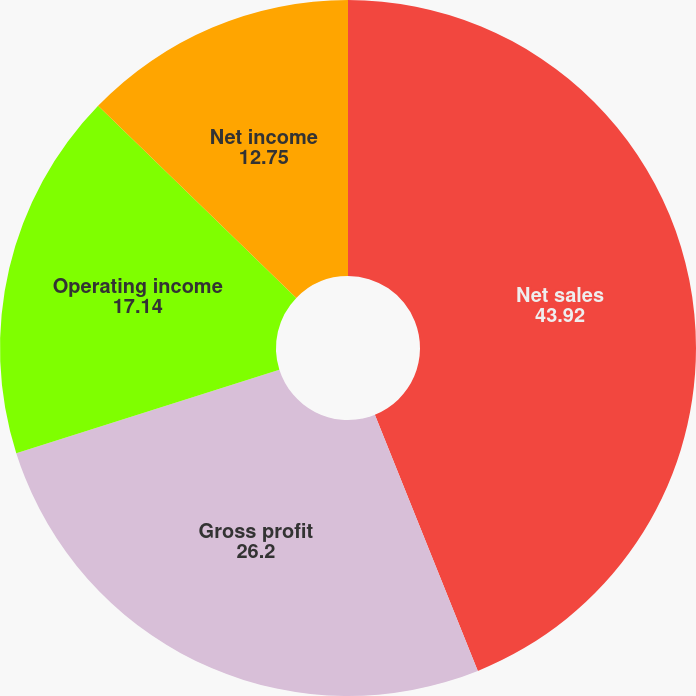<chart> <loc_0><loc_0><loc_500><loc_500><pie_chart><fcel>Net sales<fcel>Gross profit<fcel>Operating income<fcel>Net income<fcel>Diluted net income per common<nl><fcel>43.92%<fcel>26.2%<fcel>17.14%<fcel>12.75%<fcel>0.0%<nl></chart> 